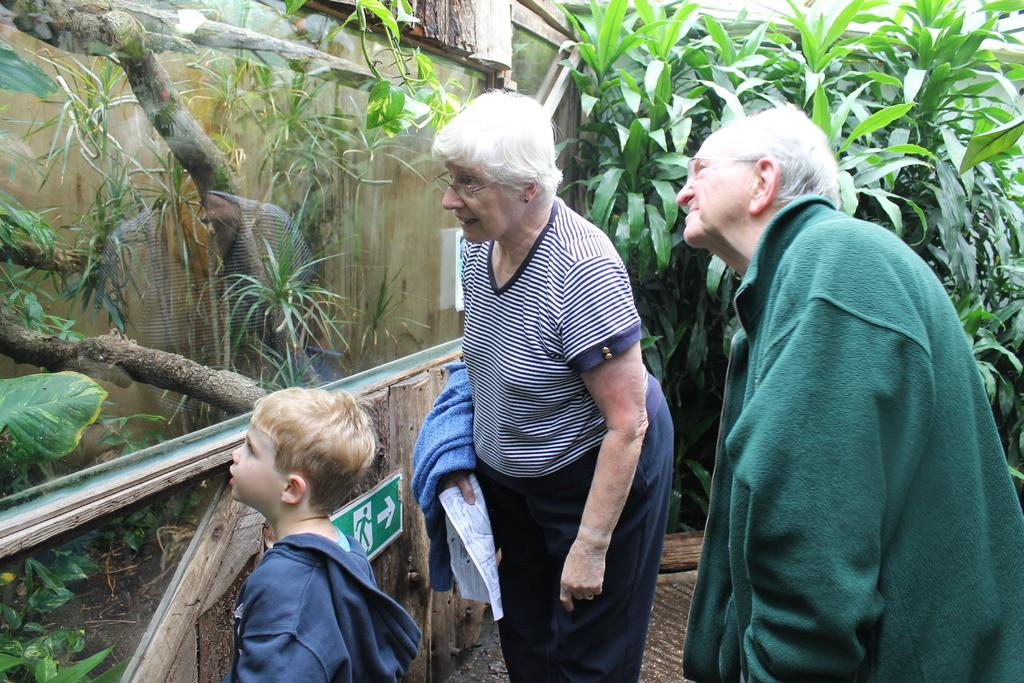How many people are present in the image? There are three people in the image: a man, a woman, and a kid. What object can be seen in the image that is typically used for drinking? There is a glass in the image. What is inside the glass in the image? There are plants in the glass. What can be seen in the background of the image? There are trees in the background of the image. What is the purpose of the match in the image? There is no match present in the image. What type of attraction can be seen in the background of the image? There is no specific attraction mentioned in the image; only trees are visible in the background. 